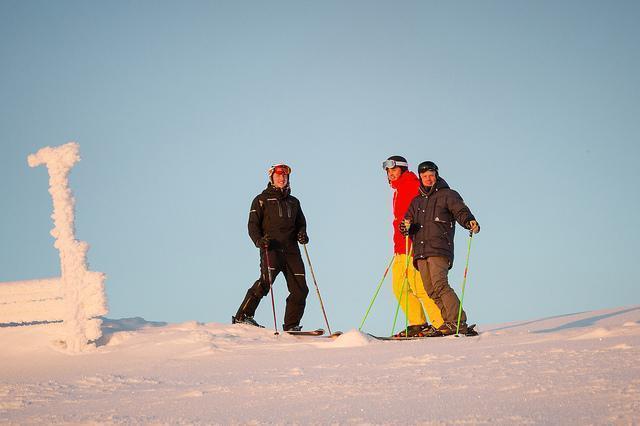Where will these men go next?
Answer the question by selecting the correct answer among the 4 following choices.
Options: Up hill, nowhere, leftward, down hill. Down hill. 